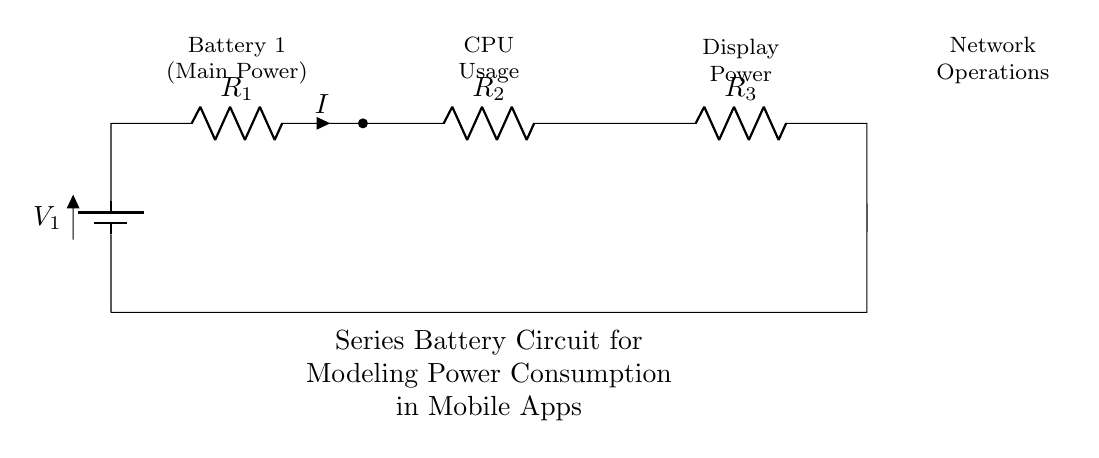What is the total resistance in this series circuit? The total resistance in a series circuit is the sum of all individual resistances. Therefore, total resistance is calculated as R1 + R2 + R3. Since no values are given, it remains an expression rather than a numerical answer.
Answer: R1 + R2 + R3 What is the current labeled in the circuit? The current is indicated in the diagram as 'I', which represents the flow of electric charge in the circuit. In a series circuit, the current is the same through all components.
Answer: I What power does the battery provide? The battery labeled as V1 provides the main power to the circuit. Its exact voltage is not mentioned, but it directly influences the power supplied to the components.
Answer: V1 Which component represents CPU usage in this circuit? The component labeled as R2 corresponds to CPU usage based on the provided labels in the diagram. Thus, it signifies a resistive load representing the power consumed by the CPU.
Answer: R2 What type of circuit is this? The circuit type is a series circuit, where components are connected end-to-end, allowing the same current to flow through each component in sequence.
Answer: Series circuit What is the role of the resistors in this circuit? Resistors R1, R2, and R3 in this circuit are used to impede the flow of current, representing different power consumption areas in the mobile app model such as CPU, display, and network operations.
Answer: Impedance 